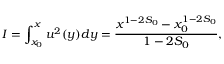Convert formula to latex. <formula><loc_0><loc_0><loc_500><loc_500>I = \int _ { x _ { 0 } } ^ { x } u ^ { 2 } ( y ) d y = \frac { x ^ { 1 - 2 S _ { 0 } } - x _ { 0 } ^ { 1 - 2 S _ { 0 } } } { 1 - 2 S _ { 0 } } ,</formula> 